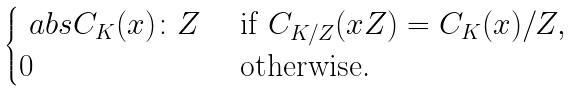<formula> <loc_0><loc_0><loc_500><loc_500>\begin{cases} \ a b s { C _ { K } ( x ) \colon Z } & \text { if } C _ { K / Z } ( x Z ) = C _ { K } ( x ) / Z , $ $ \\ 0 & \text { otherwise.} \end{cases}</formula> 